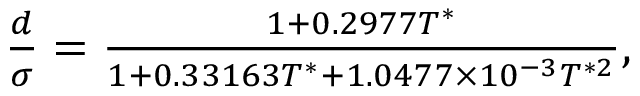<formula> <loc_0><loc_0><loc_500><loc_500>\begin{array} { r } { \frac { d } { \sigma } = \frac { 1 + 0 . 2 9 7 7 T ^ { * } } { 1 + 0 . 3 3 1 6 3 T ^ { * } + 1 . 0 4 7 7 \times 1 0 ^ { - 3 } T ^ { * 2 } } , } \end{array}</formula> 